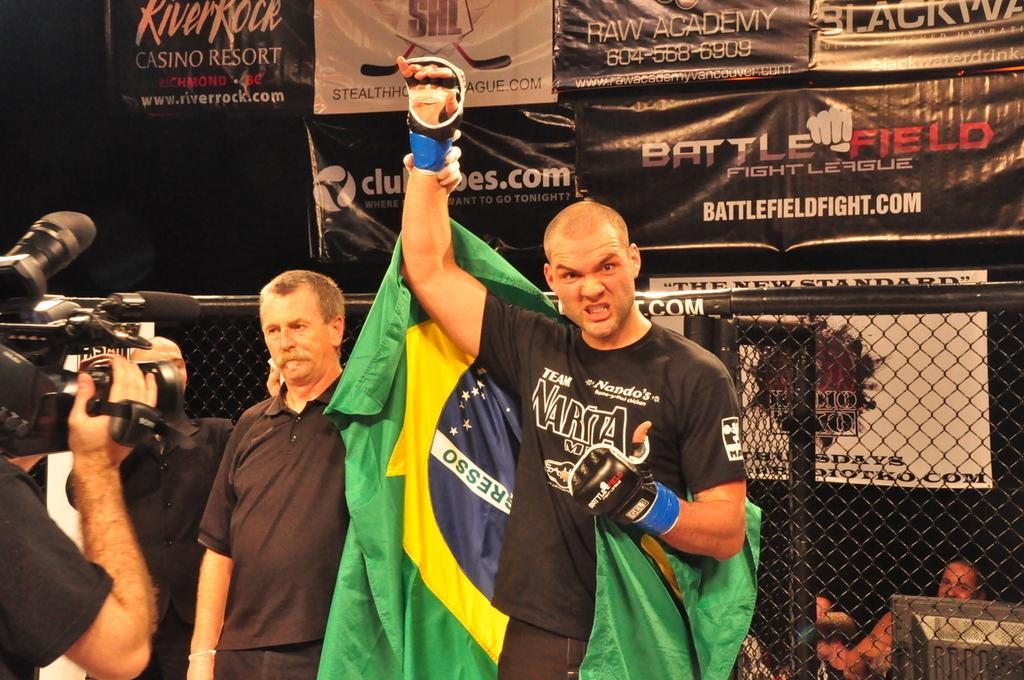<image>
Give a short and clear explanation of the subsequent image. A fighter who just won a fight wears a Narita shirt. 